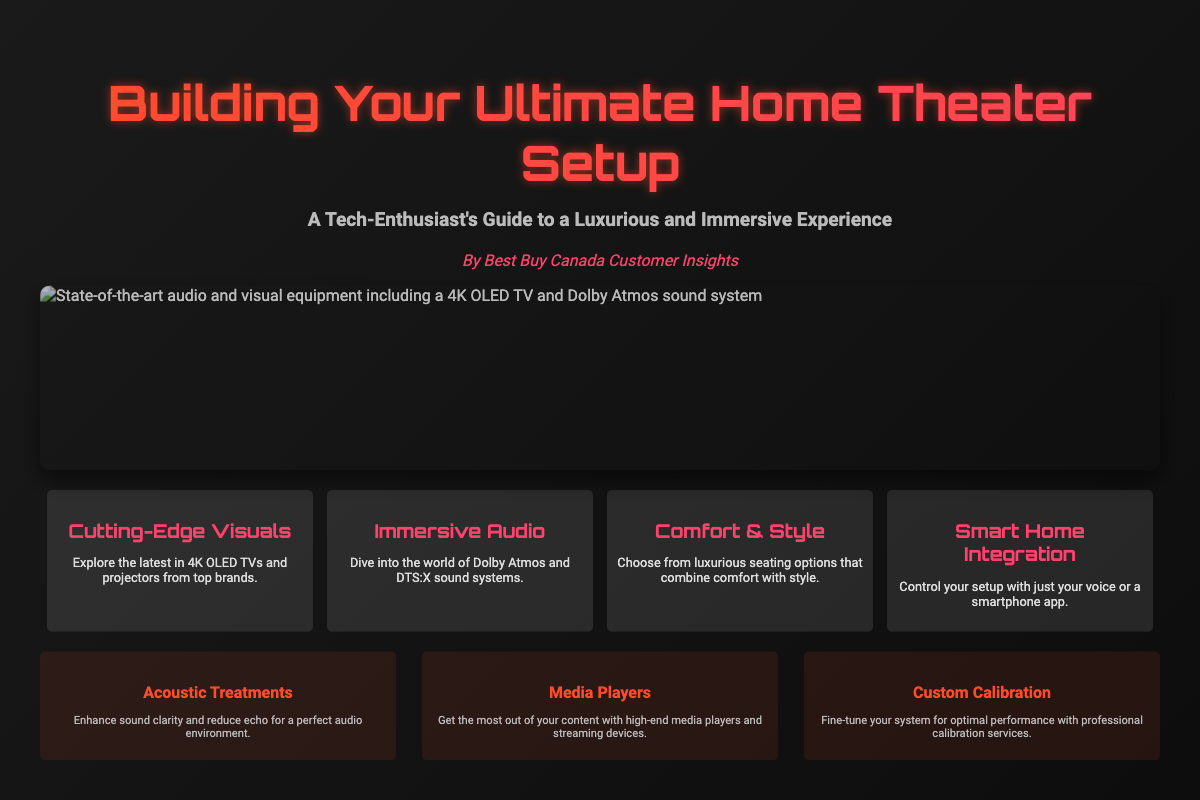What is the title of the book? The title of the book is prominently displayed at the top of the cover.
Answer: Building Your Ultimate Home Theater Setup Who is the author of the book? The author is mentioned below the subtitle on the cover.
Answer: By Best Buy Canada Customer Insights What audio technology is highlighted for immersive sound? The highlight under "Immersive Audio" mentions a specific sound technology.
Answer: Dolby Atmos What is one feature related to seating mentioned in the highlights? The "Comfort & Style" highlight discusses a specific aspect of seating options.
Answer: Luxurious seating options What visual technology is mentioned for the home theater setup? The "Cutting-Edge Visuals" highlight specifies a type of visual technology.
Answer: 4K OLED TVs Which feature enhances sound clarity and reduces echo? The additional feature section lists several features, one of which enhances sound clarity.
Answer: Acoustic Treatments What type of integration is discussed for controlling the home theater setup? The "Smart Home Integration" highlight mentions how users can control their setup.
Answer: Voice or smartphone app How many highlights are listed on the book cover? The section contains a list of features that summarize key information.
Answer: Four 